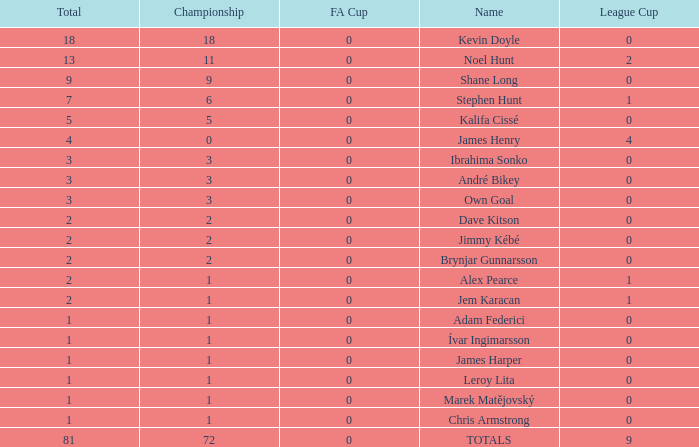Could you parse the entire table? {'header': ['Total', 'Championship', 'FA Cup', 'Name', 'League Cup'], 'rows': [['18', '18', '0', 'Kevin Doyle', '0'], ['13', '11', '0', 'Noel Hunt', '2'], ['9', '9', '0', 'Shane Long', '0'], ['7', '6', '0', 'Stephen Hunt', '1'], ['5', '5', '0', 'Kalifa Cissé', '0'], ['4', '0', '0', 'James Henry', '4'], ['3', '3', '0', 'Ibrahima Sonko', '0'], ['3', '3', '0', 'André Bikey', '0'], ['3', '3', '0', 'Own Goal', '0'], ['2', '2', '0', 'Dave Kitson', '0'], ['2', '2', '0', 'Jimmy Kébé', '0'], ['2', '2', '0', 'Brynjar Gunnarsson', '0'], ['2', '1', '0', 'Alex Pearce', '1'], ['2', '1', '0', 'Jem Karacan', '1'], ['1', '1', '0', 'Adam Federici', '0'], ['1', '1', '0', 'Ívar Ingimarsson', '0'], ['1', '1', '0', 'James Harper', '0'], ['1', '1', '0', 'Leroy Lita', '0'], ['1', '1', '0', 'Marek Matějovský', '0'], ['1', '1', '0', 'Chris Armstrong', '0'], ['81', '72', '0', 'TOTALS', '9']]} What is the total championships of James Henry that has a league cup more than 1? 0.0. 